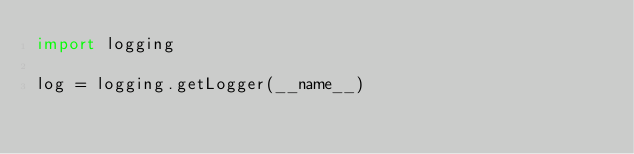<code> <loc_0><loc_0><loc_500><loc_500><_Python_>import logging

log = logging.getLogger(__name__)</code> 